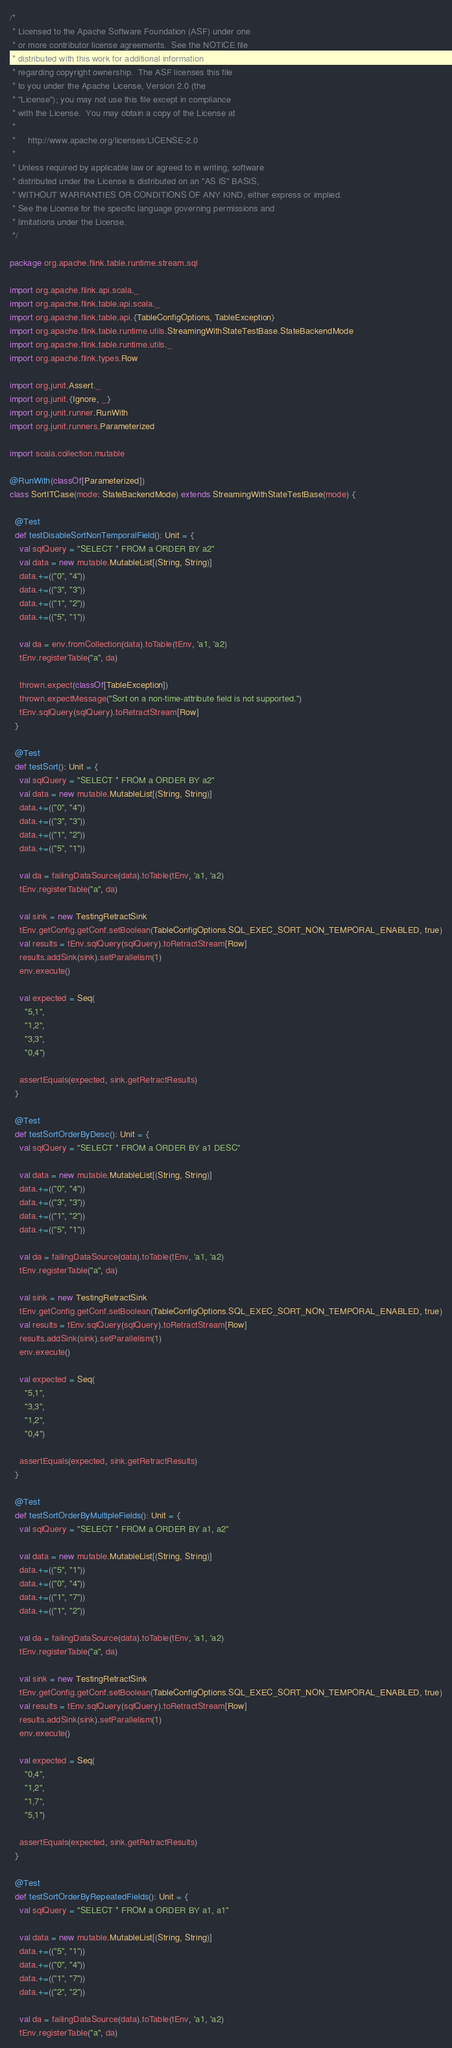<code> <loc_0><loc_0><loc_500><loc_500><_Scala_>/*
 * Licensed to the Apache Software Foundation (ASF) under one
 * or more contributor license agreements.  See the NOTICE file
 * distributed with this work for additional information
 * regarding copyright ownership.  The ASF licenses this file
 * to you under the Apache License, Version 2.0 (the
 * "License"); you may not use this file except in compliance
 * with the License.  You may obtain a copy of the License at
 *
 *     http://www.apache.org/licenses/LICENSE-2.0
 *
 * Unless required by applicable law or agreed to in writing, software
 * distributed under the License is distributed on an "AS IS" BASIS,
 * WITHOUT WARRANTIES OR CONDITIONS OF ANY KIND, either express or implied.
 * See the License for the specific language governing permissions and
 * limitations under the License.
 */

package org.apache.flink.table.runtime.stream.sql

import org.apache.flink.api.scala._
import org.apache.flink.table.api.scala._
import org.apache.flink.table.api.{TableConfigOptions, TableException}
import org.apache.flink.table.runtime.utils.StreamingWithStateTestBase.StateBackendMode
import org.apache.flink.table.runtime.utils._
import org.apache.flink.types.Row

import org.junit.Assert._
import org.junit.{Ignore, _}
import org.junit.runner.RunWith
import org.junit.runners.Parameterized

import scala.collection.mutable

@RunWith(classOf[Parameterized])
class SortITCase(mode: StateBackendMode) extends StreamingWithStateTestBase(mode) {

  @Test
  def testDisableSortNonTemporalField(): Unit = {
    val sqlQuery = "SELECT * FROM a ORDER BY a2"
    val data = new mutable.MutableList[(String, String)]
    data.+=(("0", "4"))
    data.+=(("3", "3"))
    data.+=(("1", "2"))
    data.+=(("5", "1"))

    val da = env.fromCollection(data).toTable(tEnv, 'a1, 'a2)
    tEnv.registerTable("a", da)

    thrown.expect(classOf[TableException])
    thrown.expectMessage("Sort on a non-time-attribute field is not supported.")
    tEnv.sqlQuery(sqlQuery).toRetractStream[Row]
  }

  @Test
  def testSort(): Unit = {
    val sqlQuery = "SELECT * FROM a ORDER BY a2"
    val data = new mutable.MutableList[(String, String)]
    data.+=(("0", "4"))
    data.+=(("3", "3"))
    data.+=(("1", "2"))
    data.+=(("5", "1"))

    val da = failingDataSource(data).toTable(tEnv, 'a1, 'a2)
    tEnv.registerTable("a", da)

    val sink = new TestingRetractSink
    tEnv.getConfig.getConf.setBoolean(TableConfigOptions.SQL_EXEC_SORT_NON_TEMPORAL_ENABLED, true)
    val results = tEnv.sqlQuery(sqlQuery).toRetractStream[Row]
    results.addSink(sink).setParallelism(1)
    env.execute()

    val expected = Seq(
      "5,1",
      "1,2",
      "3,3",
      "0,4")

    assertEquals(expected, sink.getRetractResults)
  }

  @Test
  def testSortOrderByDesc(): Unit = {
    val sqlQuery = "SELECT * FROM a ORDER BY a1 DESC"

    val data = new mutable.MutableList[(String, String)]
    data.+=(("0", "4"))
    data.+=(("3", "3"))
    data.+=(("1", "2"))
    data.+=(("5", "1"))

    val da = failingDataSource(data).toTable(tEnv, 'a1, 'a2)
    tEnv.registerTable("a", da)

    val sink = new TestingRetractSink
    tEnv.getConfig.getConf.setBoolean(TableConfigOptions.SQL_EXEC_SORT_NON_TEMPORAL_ENABLED, true)
    val results = tEnv.sqlQuery(sqlQuery).toRetractStream[Row]
    results.addSink(sink).setParallelism(1)
    env.execute()

    val expected = Seq(
      "5,1",
      "3,3",
      "1,2",
      "0,4")

    assertEquals(expected, sink.getRetractResults)
  }

  @Test
  def testSortOrderByMultipleFields(): Unit = {
    val sqlQuery = "SELECT * FROM a ORDER BY a1, a2"

    val data = new mutable.MutableList[(String, String)]
    data.+=(("5", "1"))
    data.+=(("0", "4"))
    data.+=(("1", "7"))
    data.+=(("1", "2"))

    val da = failingDataSource(data).toTable(tEnv, 'a1, 'a2)
    tEnv.registerTable("a", da)

    val sink = new TestingRetractSink
    tEnv.getConfig.getConf.setBoolean(TableConfigOptions.SQL_EXEC_SORT_NON_TEMPORAL_ENABLED, true)
    val results = tEnv.sqlQuery(sqlQuery).toRetractStream[Row]
    results.addSink(sink).setParallelism(1)
    env.execute()

    val expected = Seq(
      "0,4",
      "1,2",
      "1,7",
      "5,1")

    assertEquals(expected, sink.getRetractResults)
  }

  @Test
  def testSortOrderByRepeatedFields(): Unit = {
    val sqlQuery = "SELECT * FROM a ORDER BY a1, a1"

    val data = new mutable.MutableList[(String, String)]
    data.+=(("5", "1"))
    data.+=(("0", "4"))
    data.+=(("1", "7"))
    data.+=(("2", "2"))

    val da = failingDataSource(data).toTable(tEnv, 'a1, 'a2)
    tEnv.registerTable("a", da)
</code> 